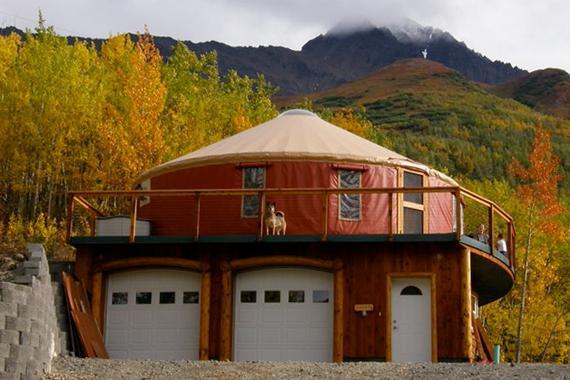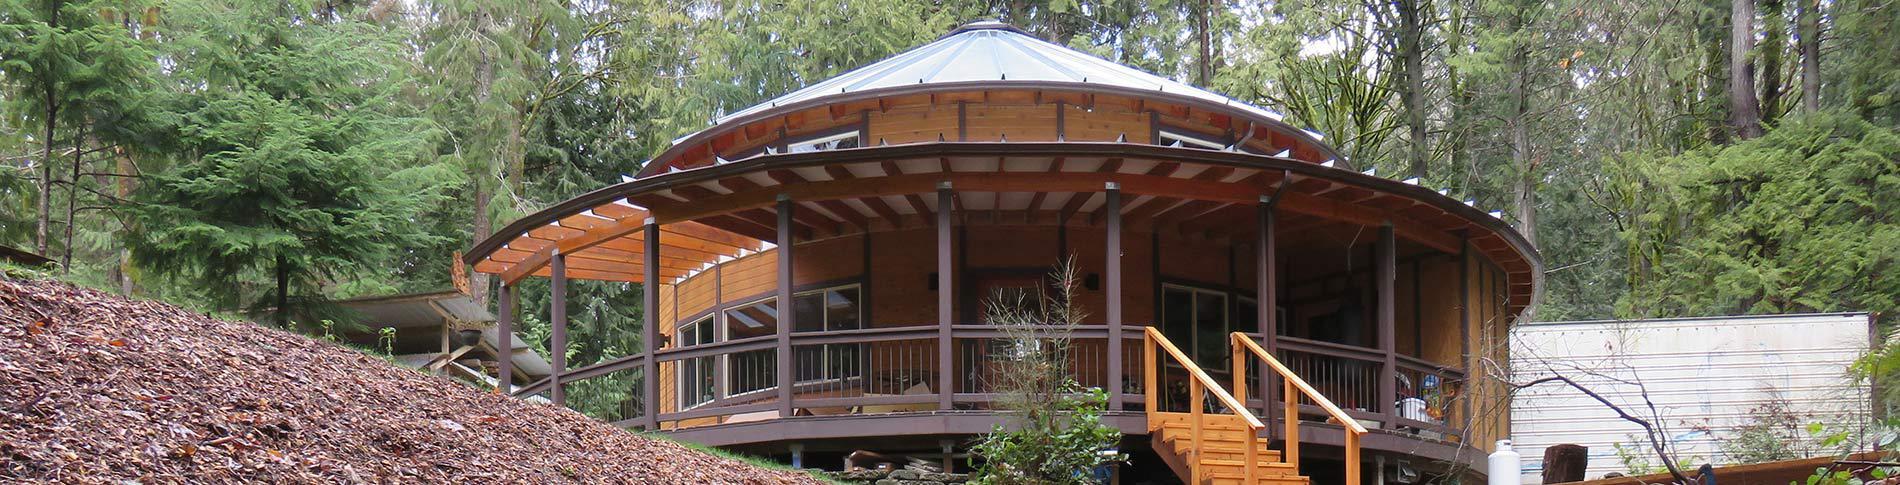The first image is the image on the left, the second image is the image on the right. Considering the images on both sides, is "In one image, a yurt with similar colored walls and ceiling with a dark rim where the roof connects, has a door, but no windows." valid? Answer yes or no. No. 